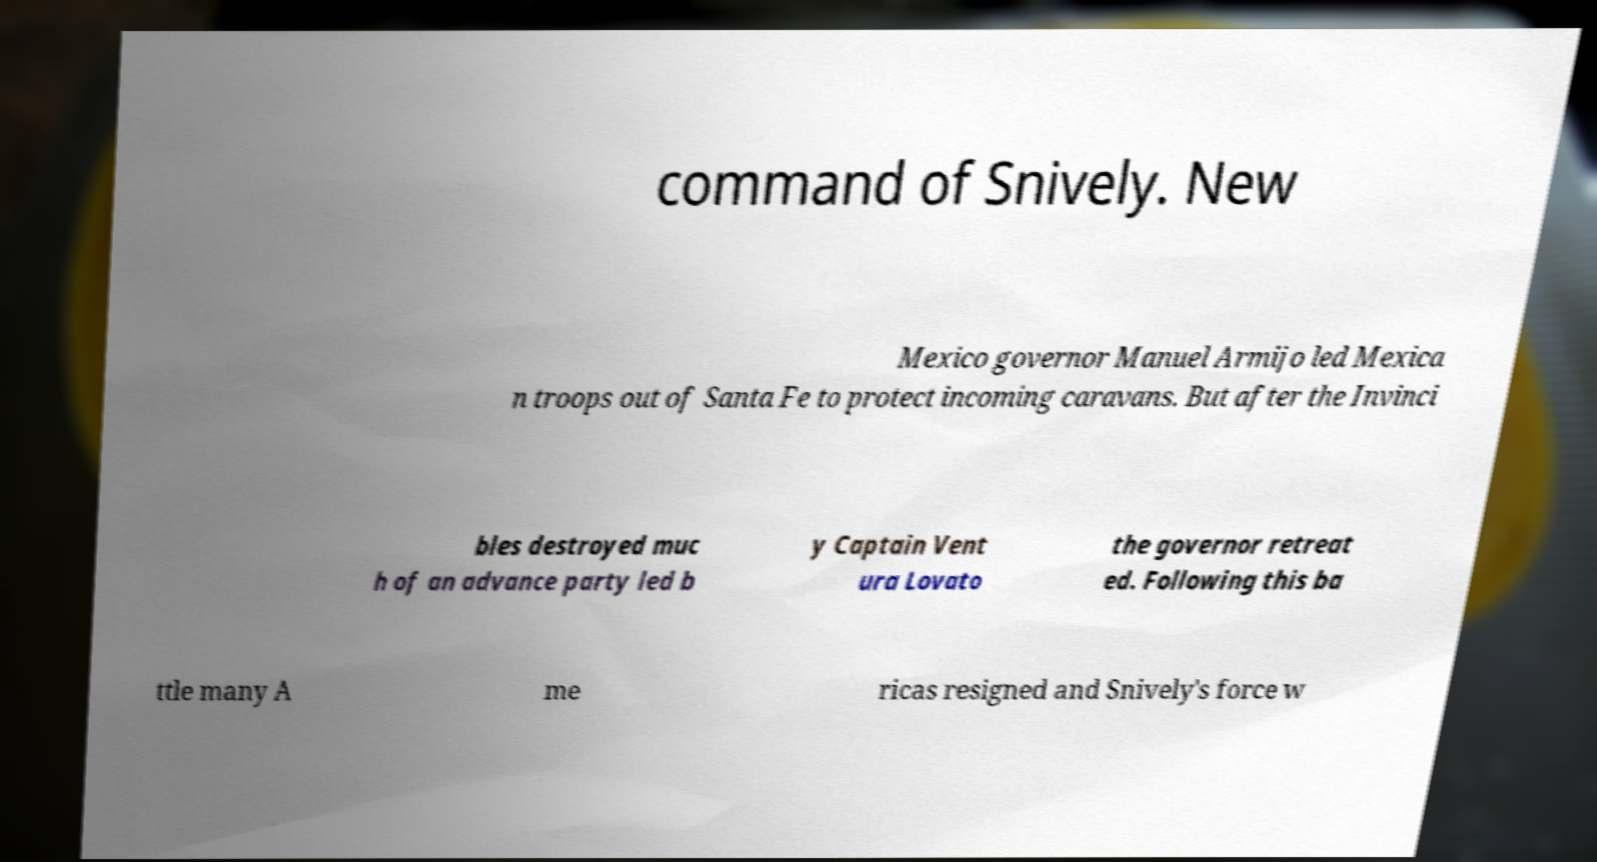Please read and relay the text visible in this image. What does it say? command of Snively. New Mexico governor Manuel Armijo led Mexica n troops out of Santa Fe to protect incoming caravans. But after the Invinci bles destroyed muc h of an advance party led b y Captain Vent ura Lovato the governor retreat ed. Following this ba ttle many A me ricas resigned and Snively's force w 